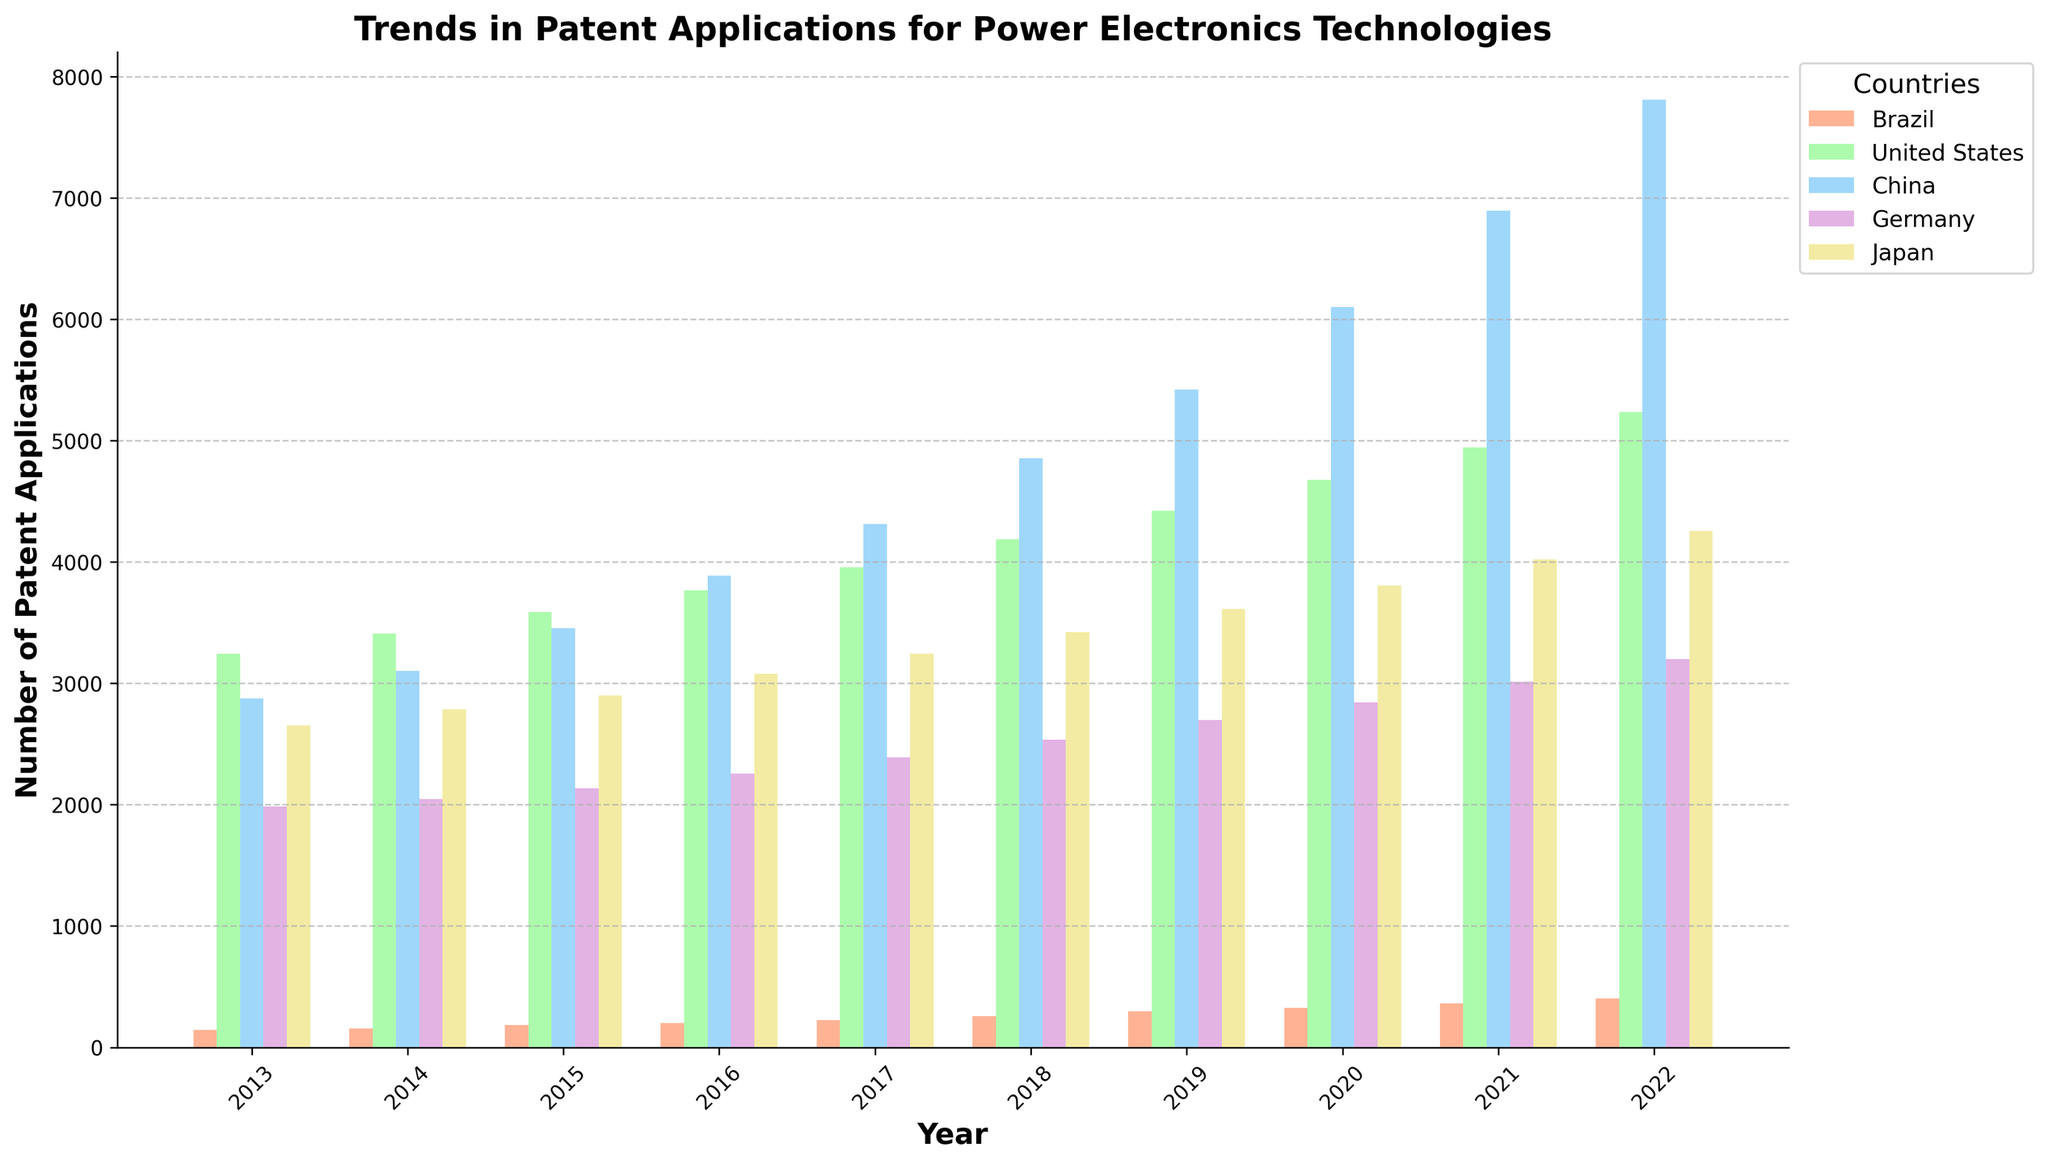What's the trend in the number of patent applications for China from 2013 to 2022? The number of patent applications for China shows an increasing trend each year, starting from 2876 in 2013 and reaching 7812 by 2022.
Answer: Increasing Which country had the highest number of patent applications in 2019? In 2019, China had the highest number of patent applications with 5421, as visually indicated by the tallest bar for that year.
Answer: China What is the difference in the number of patent applications between Brazil and the United States in 2022? In 2022, Brazil had 401 patent applications, and the United States had 5234. The difference is 5234 - 401 = 4833.
Answer: 4833 How many more patent applications did Japan have compared to Germany in 2016? In 2016, Japan had 3078 patent applications, and Germany had 2256. The difference is 3078 - 2256 = 822.
Answer: 822 Which year saw the largest jump in patent applications for Brazil, and by how many? The largest jump for Brazil was between 2018 and 2019, where the number increased from 259 to 298, resulting in a difference of 298 - 259 = 39.
Answer: 2018 to 2019, 39 What is the average number of patent applications across all countries in 2017? Add the number of patent applications for Brazil (225), United States (3956), China (4312), Germany (2389), and Japan (3245) in 2017, then divide by 5. (225 + 3956 + 4312 + 2389 + 3245) / 5 = 14127 / 5 = 2825.4.
Answer: 2825.4 Which country consistently shows an increasing trend from 2013 to 2022? All countries exhibit an increasing trend in the number of patent applications from 2013 to 2022.
Answer: All countries Compare the number of patent applications between Germany and Japan in 2020. Which country had more, and by what amount? In 2020, Germany had 2845 patent applications and Japan had 3809. Japan had 3809 - 2845 = 964 more patent applications than Germany.
Answer: Japan, 964 What is the color associated with the bars representing patent applications for the United States? The United States bars are shaded in green.
Answer: Green Calculate the total number of patent applications made by Brazil from 2013 to 2022. Sum the numbers for Brazil from 2013 to 2022: (142 + 156 + 183 + 201 + 225 + 259 + 298 + 324 + 362 + 401) = 2551.
Answer: 2551 